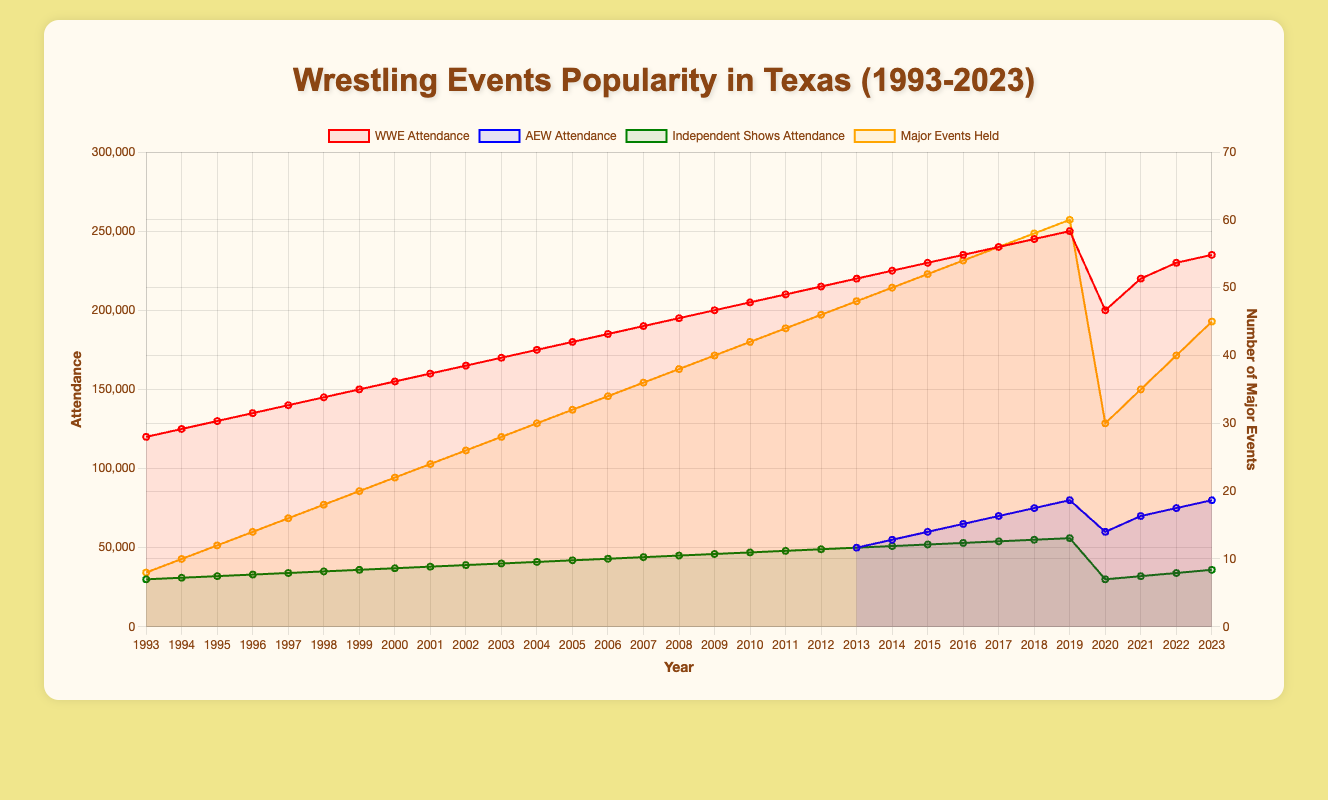Which year saw the highest attendance for WWE events in Texas? By observing the line representing WWE Attendance, it reaches its peak in 2019 with an attendance of 250,000.
Answer: 2019 Compare the attendance of AEW and Independent Shows in 2021. Which was higher and by how much? In 2021, AEW had an attendance of 70,000 and Independent Shows had 32,000. The difference is 70,000 - 32,000 = 38,000, so AEW was higher by 38,000 attendees.
Answer: AEW by 38,000 What is the average attendance for Independent Shows in Texas during 2015-2023? From 2015 to 2023, the attendances are (52,000, 53,000, 54,000, 55,000, 56,000, 30,000, 32,000, 34,000, and 36,000). The sum is 372,000, dividing by 9 gives 41,333 (approximately).
Answer: 41,333 In which year did the number of major events held in Texas drop significantly, and what was the new count? The line for Major Events Held shows a significant drop in 2020, where it goes from 60 events to 30 events.
Answer: 2020, 30 events What was the total attendance for WWE and AEW events combined in 2022? In 2022, WWE had 230,000 attendees and AEW had 75,000 attendees. Thus, the total combined is 230,000 + 75,000 = 305,000.
Answer: 305,000 In which year did AEW first start holding events in Texas, and what was the initial attendance? Observing the AEW line, it starts in 2013 with an initial attendance of 50,000.
Answer: 2013, 50,000 By how much did the attendance for WWE events in Texas increase from 1993 to 2003? WWE attendance in 1993 was 120,000, and in 2003 it was 170,000. The increase is 170,000 - 120,000 = 50,000 attendees.
Answer: 50,000 How does the trend of major events held in Texas relate to the trend of WWE attendance over the years? Both WWE Attendance and Major Events Held show an upward trend until 2019. In 2020, both metrics show a significant drop (likely due to the pandemic), with WWE attendance dropping to 200,000 and major events to 30. However, both recover somewhat by 2023.
Answer: Upward trend, dip in 2020, partial recovery What is the difference in attendance between WWE and Independent Shows in 2018? In 2018, WWE attendance was 245,000 and Independent Shows had 55,000. The difference is 245,000 - 55,000 = 190,000.
Answer: 190,000 